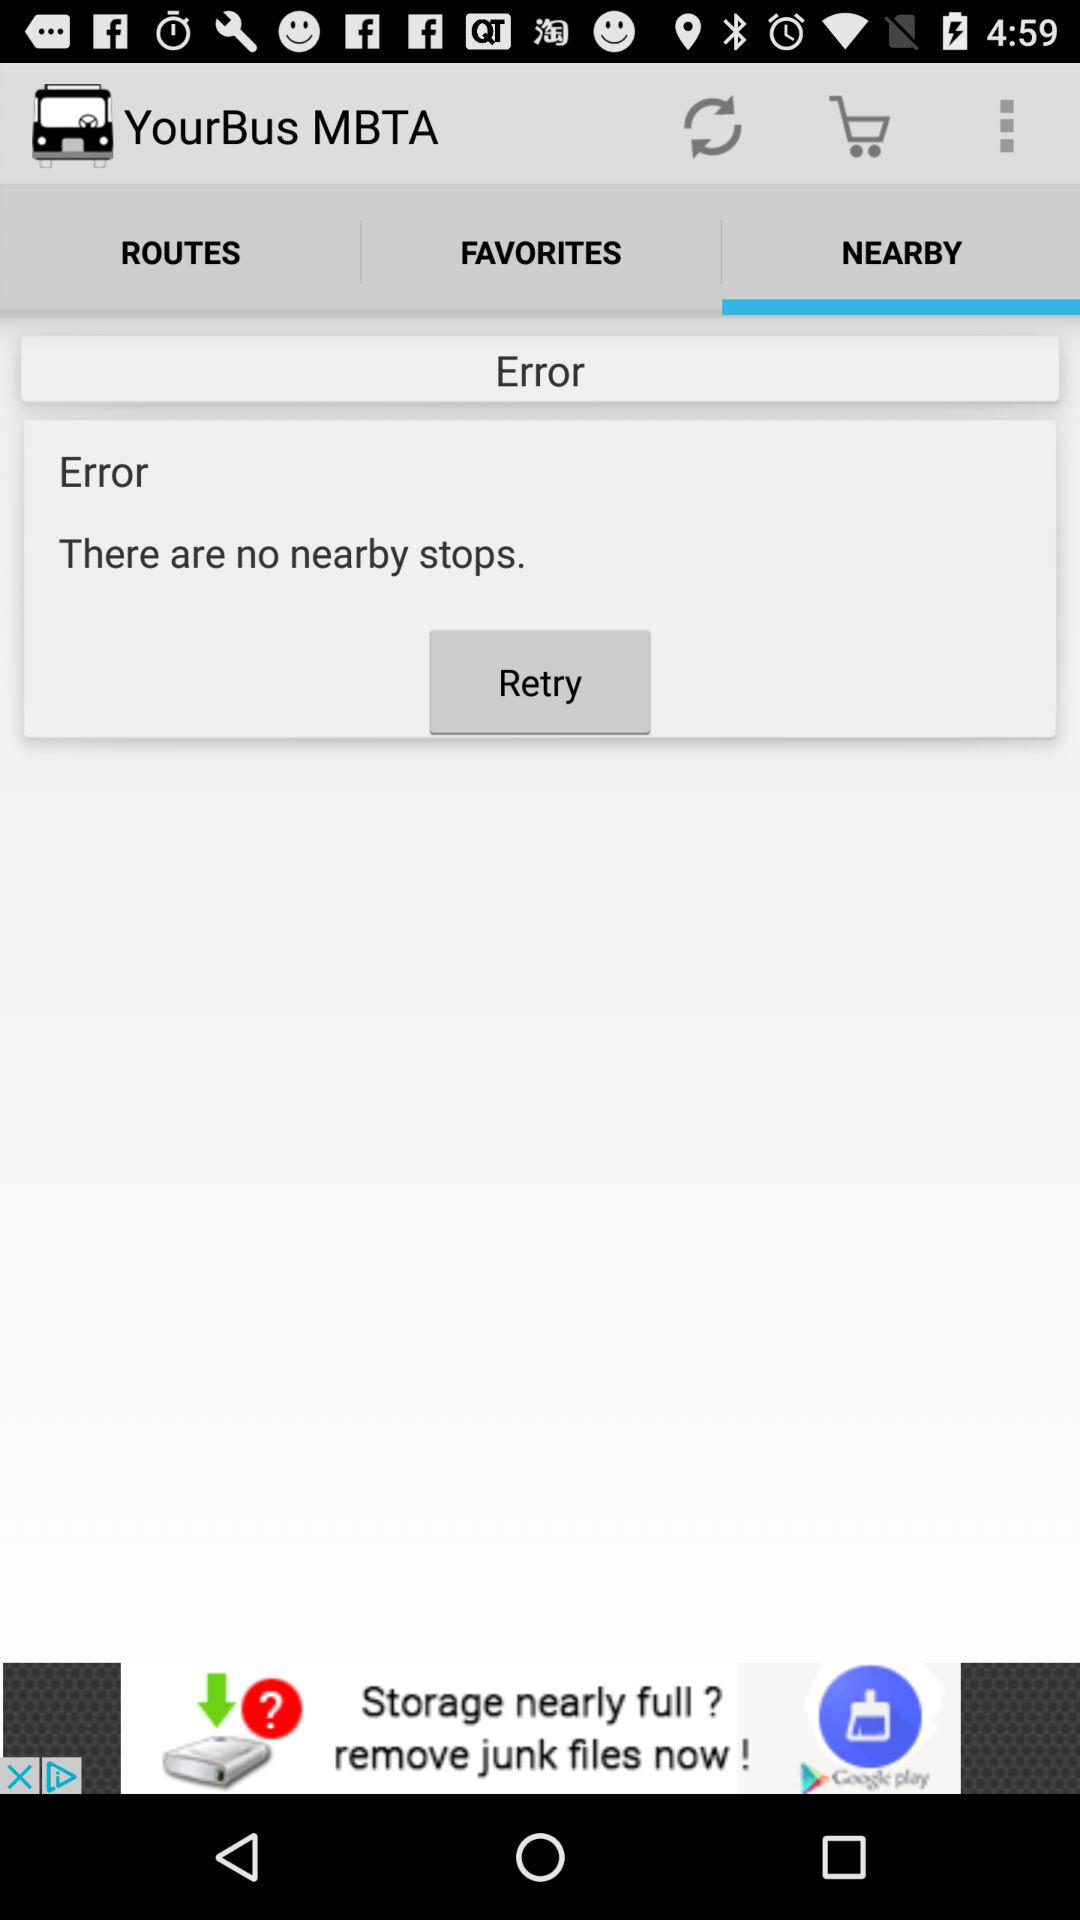What is the application name? The application name is "YourBus MBTA". 